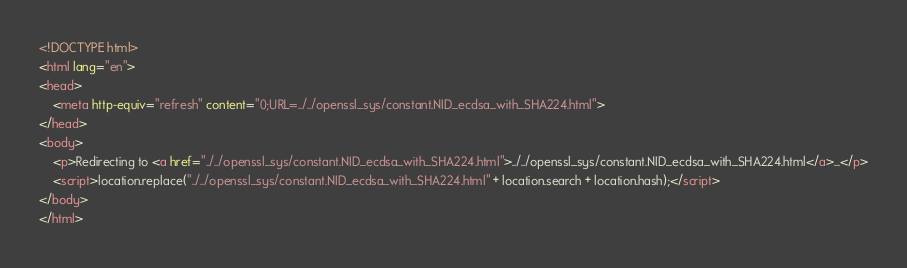Convert code to text. <code><loc_0><loc_0><loc_500><loc_500><_HTML_><!DOCTYPE html>
<html lang="en">
<head>
    <meta http-equiv="refresh" content="0;URL=../../openssl_sys/constant.NID_ecdsa_with_SHA224.html">
</head>
<body>
    <p>Redirecting to <a href="../../openssl_sys/constant.NID_ecdsa_with_SHA224.html">../../openssl_sys/constant.NID_ecdsa_with_SHA224.html</a>...</p>
    <script>location.replace("../../openssl_sys/constant.NID_ecdsa_with_SHA224.html" + location.search + location.hash);</script>
</body>
</html></code> 